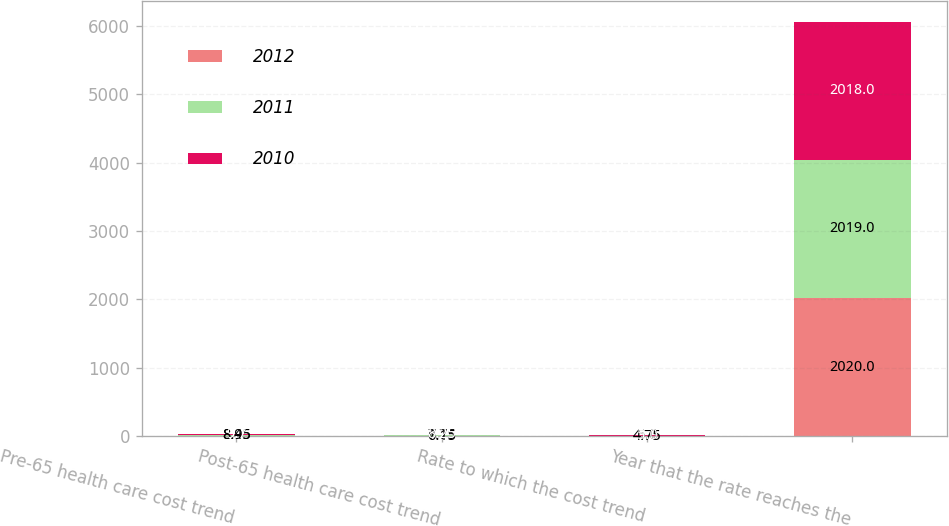<chart> <loc_0><loc_0><loc_500><loc_500><stacked_bar_chart><ecel><fcel>Pre-65 health care cost trend<fcel>Post-65 health care cost trend<fcel>Rate to which the cost trend<fcel>Year that the rate reaches the<nl><fcel>2012<fcel>8.45<fcel>6.15<fcel>4.75<fcel>2020<nl><fcel>2011<fcel>8.95<fcel>7.75<fcel>5<fcel>2019<nl><fcel>2010<fcel>9.7<fcel>8.25<fcel>5<fcel>2018<nl></chart> 